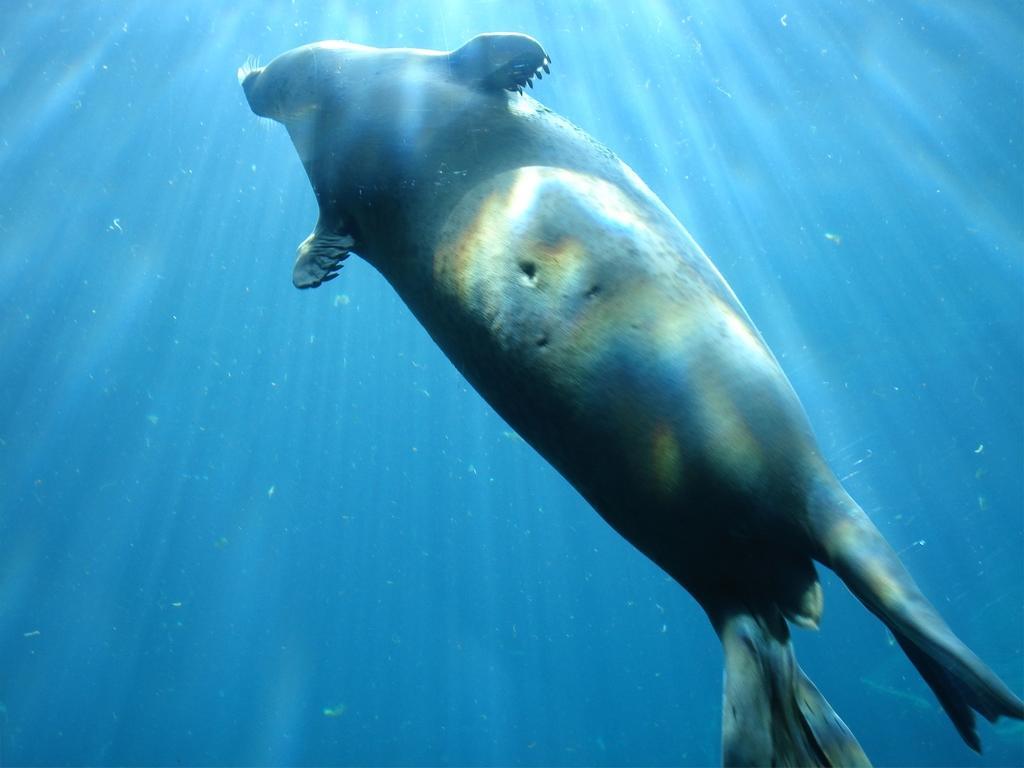Describe this image in one or two sentences. In this picture we can see fish in the water. 